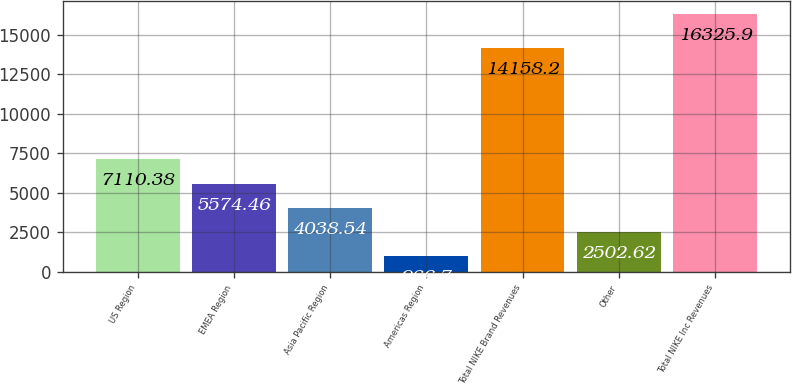<chart> <loc_0><loc_0><loc_500><loc_500><bar_chart><fcel>US Region<fcel>EMEA Region<fcel>Asia Pacific Region<fcel>Americas Region<fcel>Total NIKE Brand Revenues<fcel>Other<fcel>Total NIKE Inc Revenues<nl><fcel>7110.38<fcel>5574.46<fcel>4038.54<fcel>966.7<fcel>14158.2<fcel>2502.62<fcel>16325.9<nl></chart> 